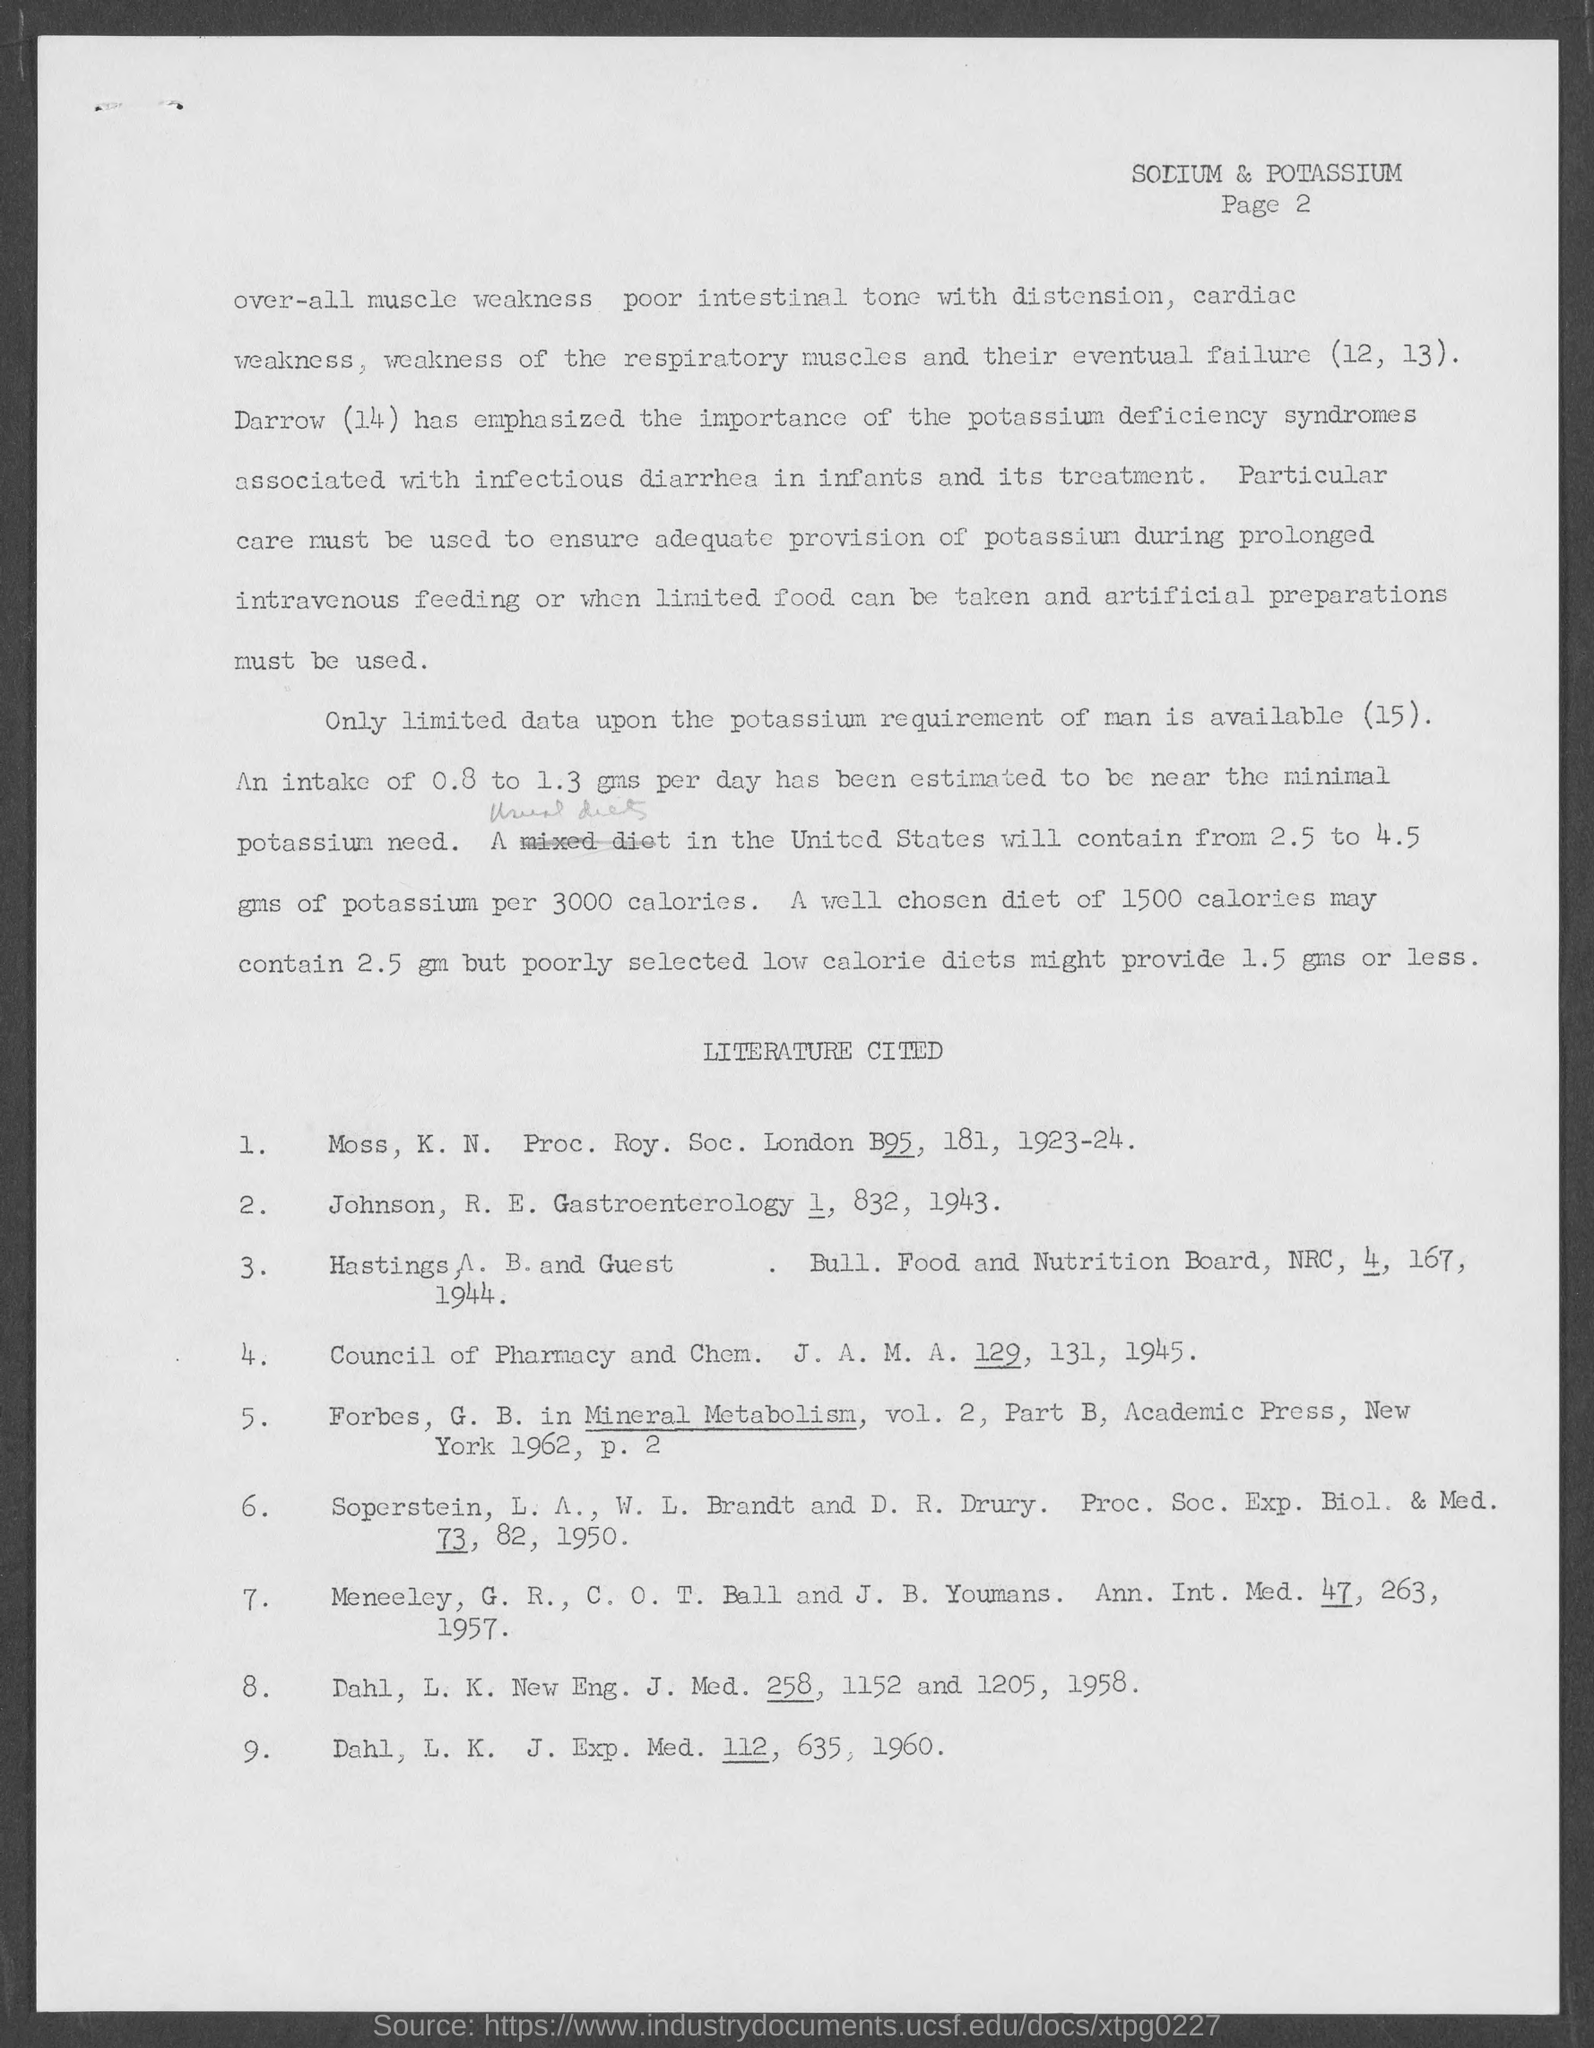Outline some significant characteristics in this image. I am currently on page 2. 